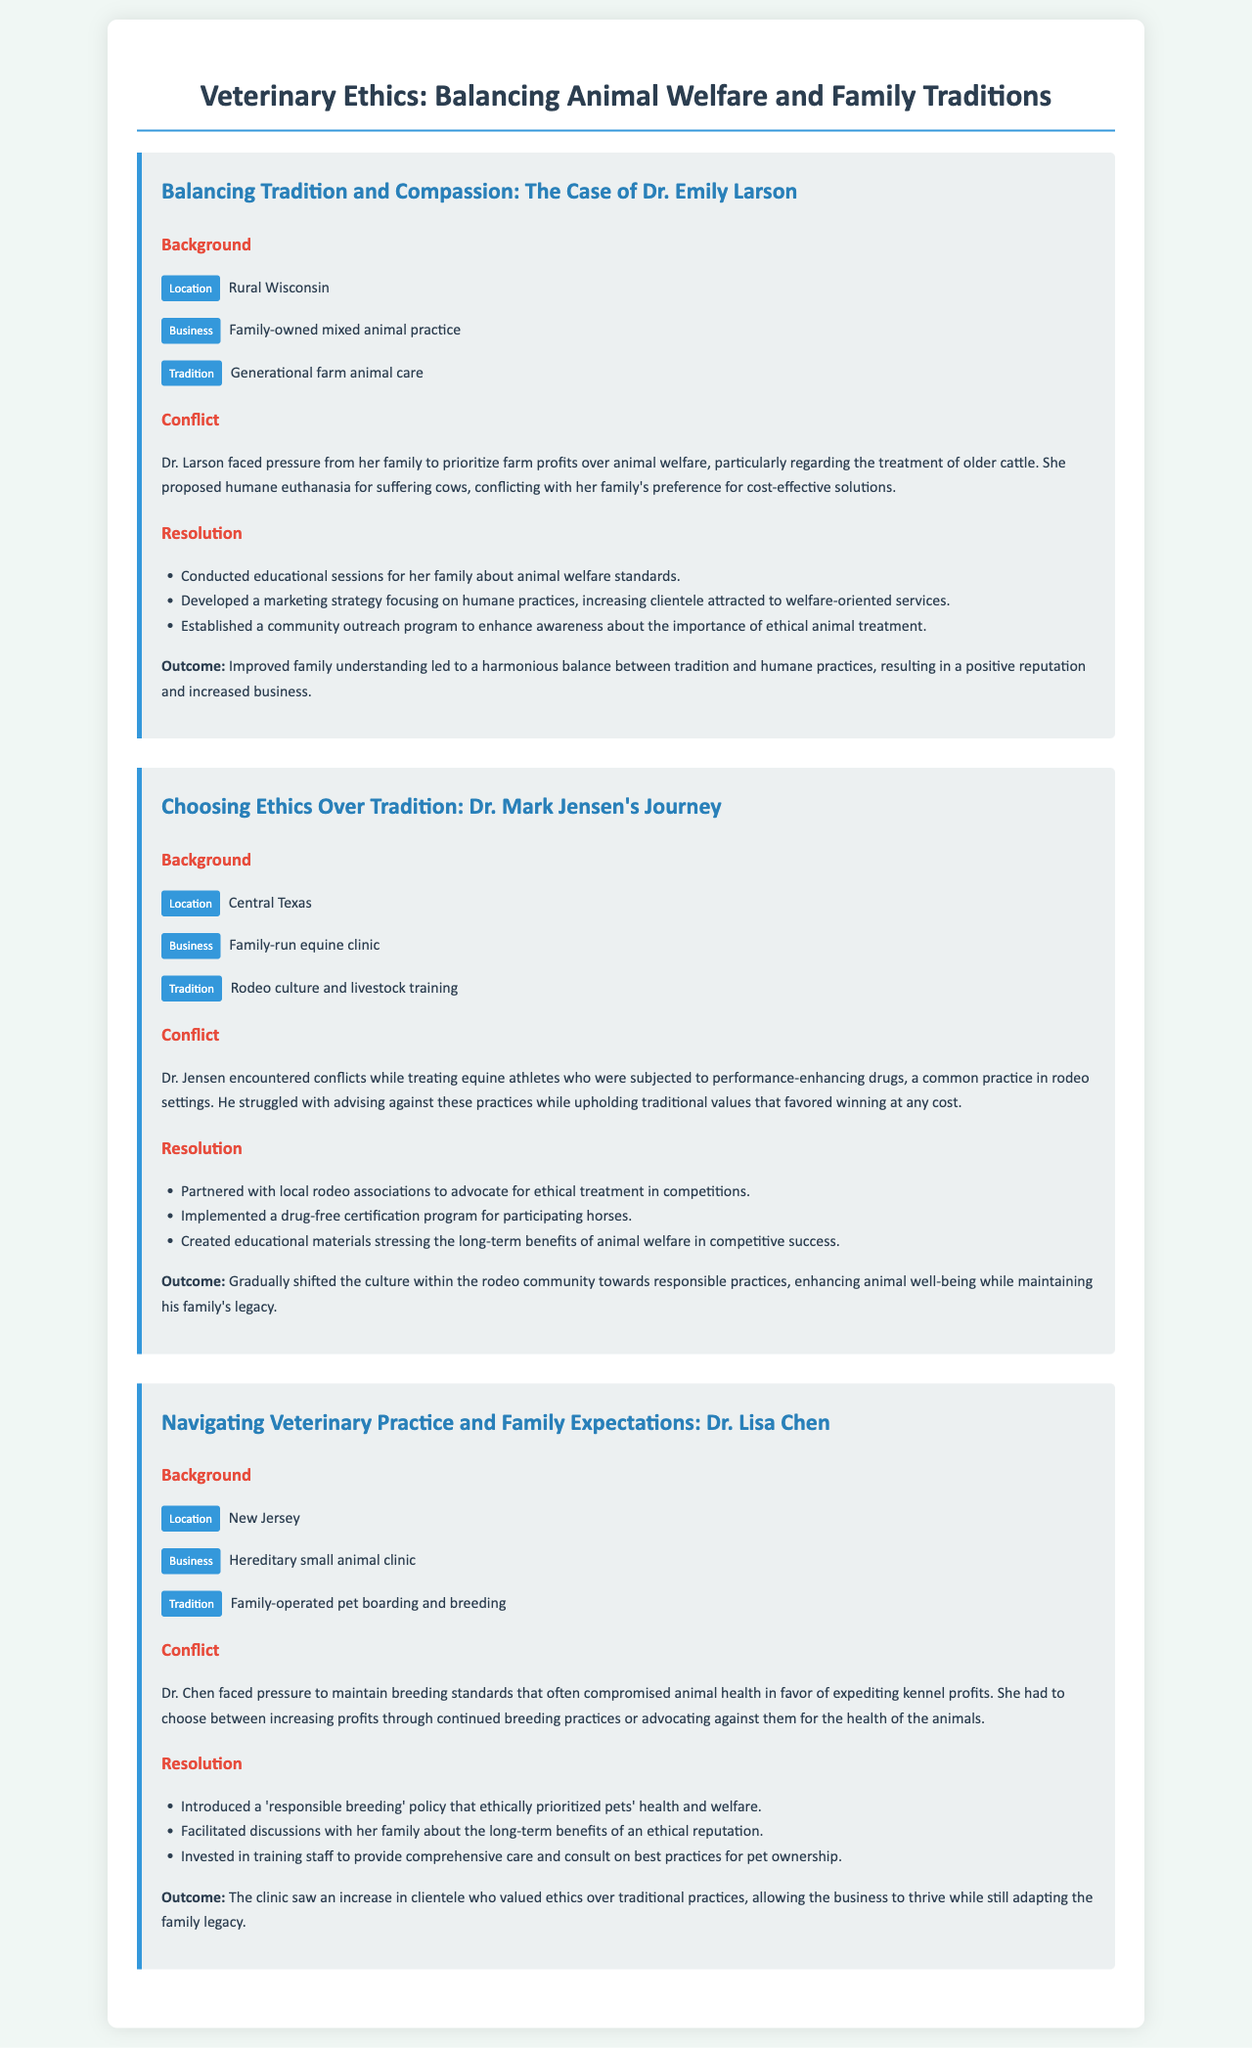What is the location of Dr. Emily Larson's practice? The location mentioned for Dr. Emily Larson's practice is Rural Wisconsin.
Answer: Rural Wisconsin What did Dr. Mark Jensen implement for participating horses? Dr. Mark Jensen implemented a drug-free certification program for participating horses at his clinic.
Answer: drug-free certification program What type of practice does Dr. Lisa Chen operate? Dr. Lisa Chen operates a hereditary small animal clinic.
Answer: hereditary small animal clinic What were Dr. Larson's educational sessions about? Dr. Larson's educational sessions were about animal welfare standards to help her family understand its importance.
Answer: animal welfare standards What challenge did Dr. Jensen face regarding equine athletes? Dr. Jensen struggled with advising against performance-enhancing drugs commonly used in rodeo settings for equine athletes.
Answer: performance-enhancing drugs What policy did Dr. Chen introduce in her clinic? Dr. Chen introduced a 'responsible breeding' policy that ethically prioritized pets' health and welfare.
Answer: 'responsible breeding' policy What was the outcome of Dr. Larson's approach to balancing tradition and humane practices? The outcome was an improved family understanding leading to a harmonious balance and positive reputation for the business.
Answer: improved family understanding In what area did Dr. Jensen's partnerships help shift culture? Dr. Jensen's partnerships helped shift the culture within the rodeo community towards responsible practices regarding animal welfare.
Answer: responsible practices How did Dr. Chen's clinic adapt to changing client values? Dr. Chen's clinic adapted by seeing an increase in clientele who valued ethics over traditional practices.
Answer: increase in clientele 